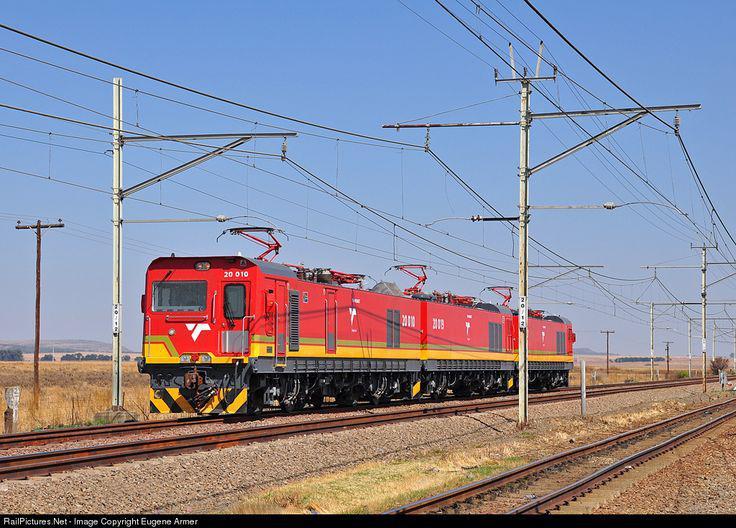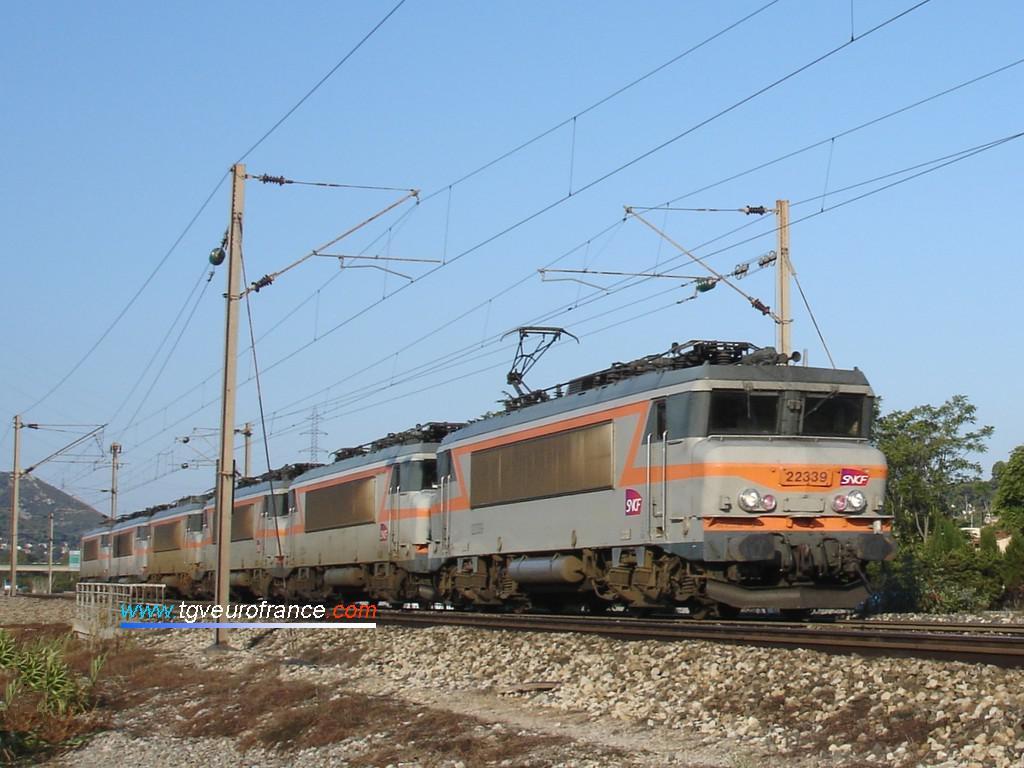The first image is the image on the left, the second image is the image on the right. Examine the images to the left and right. Is the description "The images show blue trains heading leftward." accurate? Answer yes or no. No. The first image is the image on the left, the second image is the image on the right. Evaluate the accuracy of this statement regarding the images: "In the leftmost image the train is blue with red chinese lettering.". Is it true? Answer yes or no. No. 